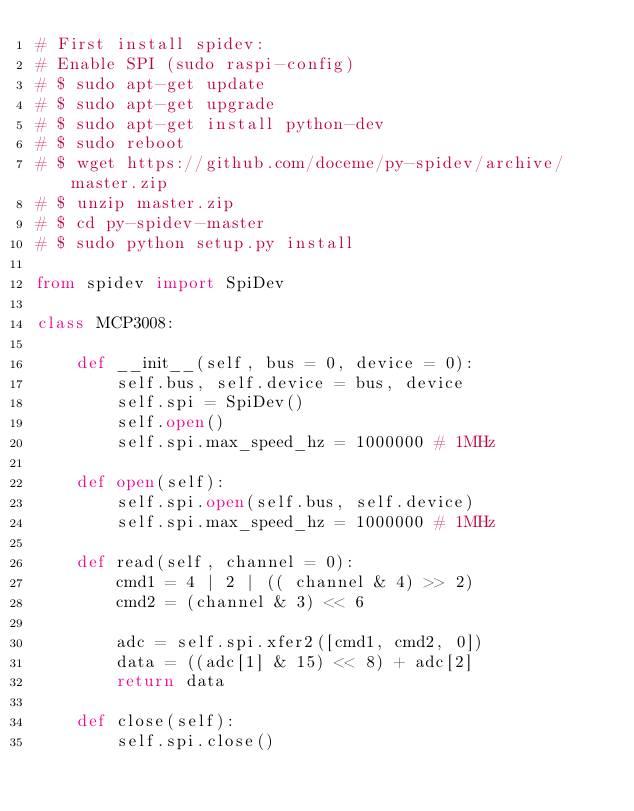<code> <loc_0><loc_0><loc_500><loc_500><_Python_># First install spidev:
# Enable SPI (sudo raspi-config)
# $ sudo apt-get update
# $ sudo apt-get upgrade
# $ sudo apt-get install python-dev
# $ sudo reboot
# $ wget https://github.com/doceme/py-spidev/archive/master.zip
# $ unzip master.zip
# $ cd py-spidev-master
# $ sudo python setup.py install

from spidev import SpiDev

class MCP3008:

    def __init__(self, bus = 0, device = 0):
        self.bus, self.device = bus, device
        self.spi = SpiDev()
        self.open()
        self.spi.max_speed_hz = 1000000 # 1MHz

    def open(self):
        self.spi.open(self.bus, self.device)
        self.spi.max_speed_hz = 1000000 # 1MHz

    def read(self, channel = 0):
        cmd1 = 4 | 2 | (( channel & 4) >> 2)
        cmd2 = (channel & 3) << 6

        adc = self.spi.xfer2([cmd1, cmd2, 0])
        data = ((adc[1] & 15) << 8) + adc[2]
        return data

    def close(self):
        self.spi.close()
</code> 